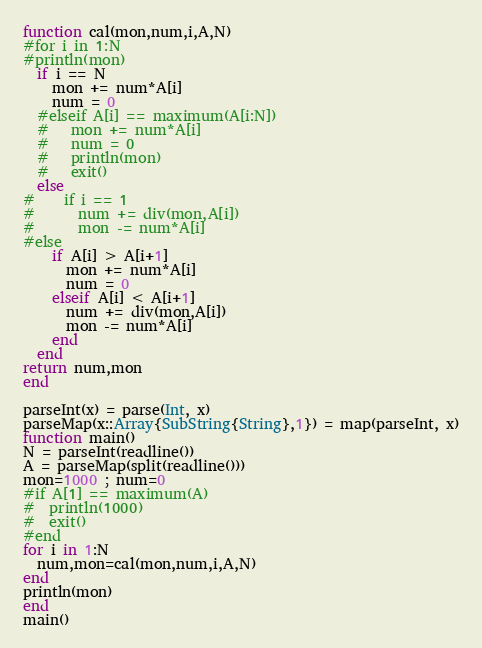Convert code to text. <code><loc_0><loc_0><loc_500><loc_500><_Julia_>function cal(mon,num,i,A,N)
#for i in 1:N
#println(mon)
  if i == N
    mon += num*A[i]
    num = 0
  #elseif A[i] == maximum(A[i:N])
  #   mon += num*A[i]
  #   num = 0
  #   println(mon)
  #   exit()
  else
#    if i == 1
#      num += div(mon,A[i])
#      mon -= num*A[i]
#else
    if A[i] > A[i+1]
      mon += num*A[i]
      num = 0
    elseif A[i] < A[i+1]
      num += div(mon,A[i])
      mon -= num*A[i]
    end
  end
return num,mon
end

parseInt(x) = parse(Int, x)
parseMap(x::Array{SubString{String},1}) = map(parseInt, x)
function main()
N = parseInt(readline())
A = parseMap(split(readline()))
mon=1000 ; num=0
#if A[1] == maximum(A)
#  println(1000)
#  exit()
#end
for i in 1:N
  num,mon=cal(mon,num,i,A,N)
end
println(mon)
end
main()
</code> 